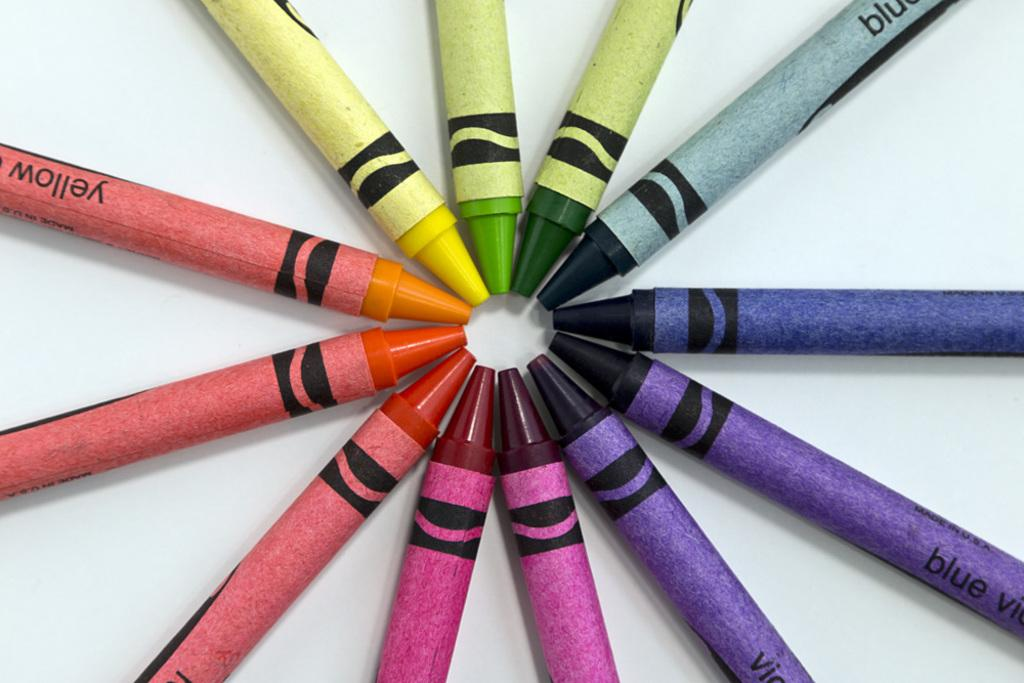<image>
Offer a succinct explanation of the picture presented. A series of crayons pointed toward each other in a circle including yellow and blue. 